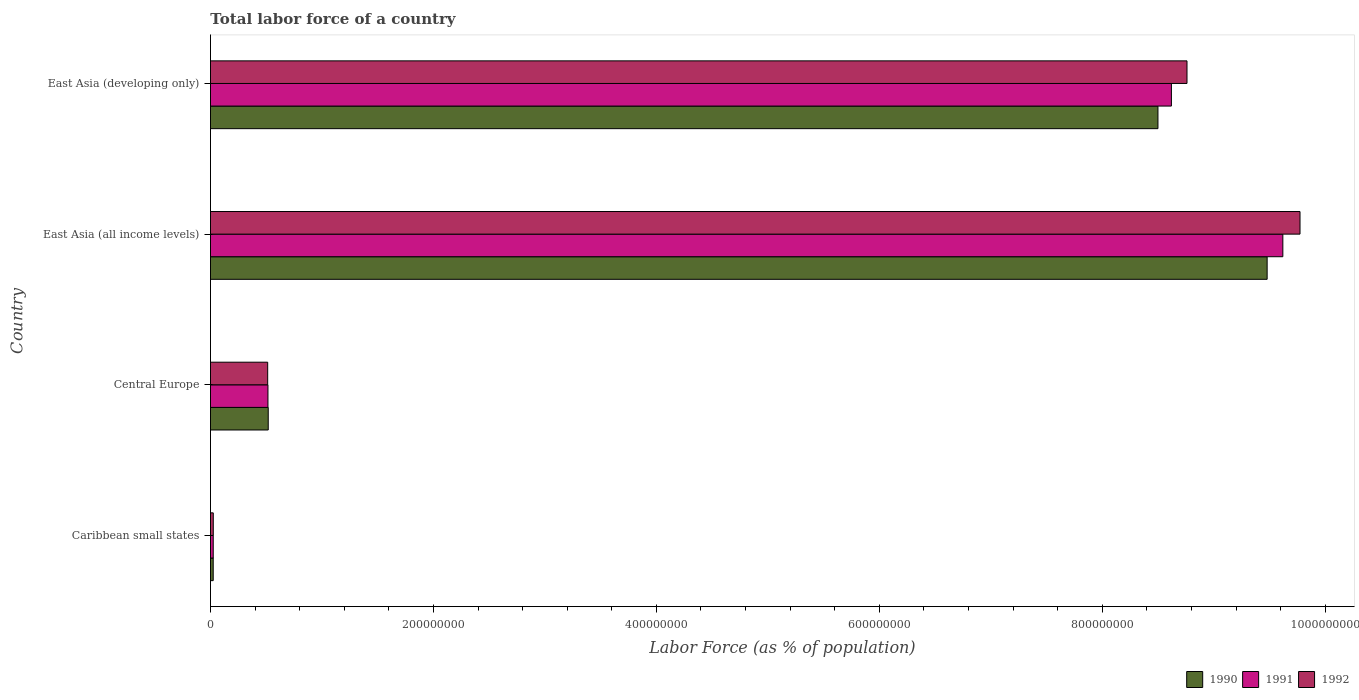How many different coloured bars are there?
Give a very brief answer. 3. Are the number of bars on each tick of the Y-axis equal?
Your answer should be very brief. Yes. How many bars are there on the 4th tick from the top?
Your answer should be compact. 3. How many bars are there on the 3rd tick from the bottom?
Keep it short and to the point. 3. What is the label of the 1st group of bars from the top?
Provide a short and direct response. East Asia (developing only). What is the percentage of labor force in 1990 in East Asia (developing only)?
Offer a very short reply. 8.50e+08. Across all countries, what is the maximum percentage of labor force in 1990?
Your answer should be very brief. 9.48e+08. Across all countries, what is the minimum percentage of labor force in 1992?
Make the answer very short. 2.52e+06. In which country was the percentage of labor force in 1991 maximum?
Provide a succinct answer. East Asia (all income levels). In which country was the percentage of labor force in 1992 minimum?
Keep it short and to the point. Caribbean small states. What is the total percentage of labor force in 1992 in the graph?
Your response must be concise. 1.91e+09. What is the difference between the percentage of labor force in 1990 in Caribbean small states and that in East Asia (all income levels)?
Your answer should be very brief. -9.45e+08. What is the difference between the percentage of labor force in 1990 in East Asia (all income levels) and the percentage of labor force in 1992 in Central Europe?
Keep it short and to the point. 8.97e+08. What is the average percentage of labor force in 1992 per country?
Provide a succinct answer. 4.77e+08. What is the difference between the percentage of labor force in 1992 and percentage of labor force in 1990 in East Asia (all income levels)?
Your response must be concise. 2.95e+07. In how many countries, is the percentage of labor force in 1991 greater than 680000000 %?
Make the answer very short. 2. What is the ratio of the percentage of labor force in 1992 in Caribbean small states to that in East Asia (developing only)?
Offer a very short reply. 0. Is the percentage of labor force in 1992 in East Asia (all income levels) less than that in East Asia (developing only)?
Offer a very short reply. No. What is the difference between the highest and the second highest percentage of labor force in 1991?
Make the answer very short. 1.00e+08. What is the difference between the highest and the lowest percentage of labor force in 1992?
Your response must be concise. 9.75e+08. What does the 1st bar from the bottom in East Asia (developing only) represents?
Offer a very short reply. 1990. Are all the bars in the graph horizontal?
Make the answer very short. Yes. How many countries are there in the graph?
Your answer should be very brief. 4. What is the difference between two consecutive major ticks on the X-axis?
Offer a terse response. 2.00e+08. What is the title of the graph?
Give a very brief answer. Total labor force of a country. What is the label or title of the X-axis?
Your answer should be very brief. Labor Force (as % of population). What is the Labor Force (as % of population) of 1990 in Caribbean small states?
Give a very brief answer. 2.47e+06. What is the Labor Force (as % of population) of 1991 in Caribbean small states?
Make the answer very short. 2.48e+06. What is the Labor Force (as % of population) of 1992 in Caribbean small states?
Provide a short and direct response. 2.52e+06. What is the Labor Force (as % of population) of 1990 in Central Europe?
Your answer should be compact. 5.18e+07. What is the Labor Force (as % of population) of 1991 in Central Europe?
Ensure brevity in your answer.  5.16e+07. What is the Labor Force (as % of population) in 1992 in Central Europe?
Ensure brevity in your answer.  5.13e+07. What is the Labor Force (as % of population) of 1990 in East Asia (all income levels)?
Offer a very short reply. 9.48e+08. What is the Labor Force (as % of population) of 1991 in East Asia (all income levels)?
Ensure brevity in your answer.  9.62e+08. What is the Labor Force (as % of population) in 1992 in East Asia (all income levels)?
Provide a succinct answer. 9.77e+08. What is the Labor Force (as % of population) in 1990 in East Asia (developing only)?
Provide a succinct answer. 8.50e+08. What is the Labor Force (as % of population) in 1991 in East Asia (developing only)?
Keep it short and to the point. 8.62e+08. What is the Labor Force (as % of population) of 1992 in East Asia (developing only)?
Provide a succinct answer. 8.76e+08. Across all countries, what is the maximum Labor Force (as % of population) of 1990?
Your response must be concise. 9.48e+08. Across all countries, what is the maximum Labor Force (as % of population) of 1991?
Your response must be concise. 9.62e+08. Across all countries, what is the maximum Labor Force (as % of population) in 1992?
Offer a terse response. 9.77e+08. Across all countries, what is the minimum Labor Force (as % of population) of 1990?
Ensure brevity in your answer.  2.47e+06. Across all countries, what is the minimum Labor Force (as % of population) in 1991?
Provide a short and direct response. 2.48e+06. Across all countries, what is the minimum Labor Force (as % of population) in 1992?
Your answer should be compact. 2.52e+06. What is the total Labor Force (as % of population) of 1990 in the graph?
Provide a short and direct response. 1.85e+09. What is the total Labor Force (as % of population) of 1991 in the graph?
Your response must be concise. 1.88e+09. What is the total Labor Force (as % of population) in 1992 in the graph?
Your answer should be compact. 1.91e+09. What is the difference between the Labor Force (as % of population) of 1990 in Caribbean small states and that in Central Europe?
Ensure brevity in your answer.  -4.93e+07. What is the difference between the Labor Force (as % of population) in 1991 in Caribbean small states and that in Central Europe?
Ensure brevity in your answer.  -4.91e+07. What is the difference between the Labor Force (as % of population) in 1992 in Caribbean small states and that in Central Europe?
Ensure brevity in your answer.  -4.88e+07. What is the difference between the Labor Force (as % of population) in 1990 in Caribbean small states and that in East Asia (all income levels)?
Give a very brief answer. -9.45e+08. What is the difference between the Labor Force (as % of population) of 1991 in Caribbean small states and that in East Asia (all income levels)?
Make the answer very short. -9.60e+08. What is the difference between the Labor Force (as % of population) of 1992 in Caribbean small states and that in East Asia (all income levels)?
Provide a succinct answer. -9.75e+08. What is the difference between the Labor Force (as % of population) in 1990 in Caribbean small states and that in East Asia (developing only)?
Make the answer very short. -8.47e+08. What is the difference between the Labor Force (as % of population) in 1991 in Caribbean small states and that in East Asia (developing only)?
Your answer should be compact. -8.60e+08. What is the difference between the Labor Force (as % of population) in 1992 in Caribbean small states and that in East Asia (developing only)?
Offer a very short reply. -8.73e+08. What is the difference between the Labor Force (as % of population) of 1990 in Central Europe and that in East Asia (all income levels)?
Keep it short and to the point. -8.96e+08. What is the difference between the Labor Force (as % of population) of 1991 in Central Europe and that in East Asia (all income levels)?
Offer a terse response. -9.10e+08. What is the difference between the Labor Force (as % of population) of 1992 in Central Europe and that in East Asia (all income levels)?
Your response must be concise. -9.26e+08. What is the difference between the Labor Force (as % of population) in 1990 in Central Europe and that in East Asia (developing only)?
Provide a short and direct response. -7.98e+08. What is the difference between the Labor Force (as % of population) of 1991 in Central Europe and that in East Asia (developing only)?
Make the answer very short. -8.10e+08. What is the difference between the Labor Force (as % of population) of 1992 in Central Europe and that in East Asia (developing only)?
Provide a succinct answer. -8.25e+08. What is the difference between the Labor Force (as % of population) in 1990 in East Asia (all income levels) and that in East Asia (developing only)?
Give a very brief answer. 9.79e+07. What is the difference between the Labor Force (as % of population) of 1991 in East Asia (all income levels) and that in East Asia (developing only)?
Your answer should be compact. 1.00e+08. What is the difference between the Labor Force (as % of population) in 1992 in East Asia (all income levels) and that in East Asia (developing only)?
Give a very brief answer. 1.01e+08. What is the difference between the Labor Force (as % of population) in 1990 in Caribbean small states and the Labor Force (as % of population) in 1991 in Central Europe?
Give a very brief answer. -4.91e+07. What is the difference between the Labor Force (as % of population) of 1990 in Caribbean small states and the Labor Force (as % of population) of 1992 in Central Europe?
Ensure brevity in your answer.  -4.89e+07. What is the difference between the Labor Force (as % of population) of 1991 in Caribbean small states and the Labor Force (as % of population) of 1992 in Central Europe?
Your answer should be very brief. -4.89e+07. What is the difference between the Labor Force (as % of population) in 1990 in Caribbean small states and the Labor Force (as % of population) in 1991 in East Asia (all income levels)?
Your answer should be compact. -9.60e+08. What is the difference between the Labor Force (as % of population) in 1990 in Caribbean small states and the Labor Force (as % of population) in 1992 in East Asia (all income levels)?
Ensure brevity in your answer.  -9.75e+08. What is the difference between the Labor Force (as % of population) of 1991 in Caribbean small states and the Labor Force (as % of population) of 1992 in East Asia (all income levels)?
Provide a succinct answer. -9.75e+08. What is the difference between the Labor Force (as % of population) of 1990 in Caribbean small states and the Labor Force (as % of population) of 1991 in East Asia (developing only)?
Provide a short and direct response. -8.60e+08. What is the difference between the Labor Force (as % of population) in 1990 in Caribbean small states and the Labor Force (as % of population) in 1992 in East Asia (developing only)?
Give a very brief answer. -8.74e+08. What is the difference between the Labor Force (as % of population) of 1991 in Caribbean small states and the Labor Force (as % of population) of 1992 in East Asia (developing only)?
Make the answer very short. -8.74e+08. What is the difference between the Labor Force (as % of population) of 1990 in Central Europe and the Labor Force (as % of population) of 1991 in East Asia (all income levels)?
Keep it short and to the point. -9.10e+08. What is the difference between the Labor Force (as % of population) of 1990 in Central Europe and the Labor Force (as % of population) of 1992 in East Asia (all income levels)?
Your response must be concise. -9.26e+08. What is the difference between the Labor Force (as % of population) in 1991 in Central Europe and the Labor Force (as % of population) in 1992 in East Asia (all income levels)?
Your response must be concise. -9.26e+08. What is the difference between the Labor Force (as % of population) of 1990 in Central Europe and the Labor Force (as % of population) of 1991 in East Asia (developing only)?
Your response must be concise. -8.10e+08. What is the difference between the Labor Force (as % of population) in 1990 in Central Europe and the Labor Force (as % of population) in 1992 in East Asia (developing only)?
Offer a terse response. -8.24e+08. What is the difference between the Labor Force (as % of population) of 1991 in Central Europe and the Labor Force (as % of population) of 1992 in East Asia (developing only)?
Make the answer very short. -8.24e+08. What is the difference between the Labor Force (as % of population) in 1990 in East Asia (all income levels) and the Labor Force (as % of population) in 1991 in East Asia (developing only)?
Offer a terse response. 8.59e+07. What is the difference between the Labor Force (as % of population) of 1990 in East Asia (all income levels) and the Labor Force (as % of population) of 1992 in East Asia (developing only)?
Provide a short and direct response. 7.19e+07. What is the difference between the Labor Force (as % of population) in 1991 in East Asia (all income levels) and the Labor Force (as % of population) in 1992 in East Asia (developing only)?
Provide a succinct answer. 8.60e+07. What is the average Labor Force (as % of population) in 1990 per country?
Your answer should be compact. 4.63e+08. What is the average Labor Force (as % of population) in 1991 per country?
Provide a short and direct response. 4.70e+08. What is the average Labor Force (as % of population) of 1992 per country?
Ensure brevity in your answer.  4.77e+08. What is the difference between the Labor Force (as % of population) in 1990 and Labor Force (as % of population) in 1991 in Caribbean small states?
Give a very brief answer. -9246. What is the difference between the Labor Force (as % of population) in 1990 and Labor Force (as % of population) in 1992 in Caribbean small states?
Provide a short and direct response. -5.15e+04. What is the difference between the Labor Force (as % of population) of 1991 and Labor Force (as % of population) of 1992 in Caribbean small states?
Your answer should be very brief. -4.23e+04. What is the difference between the Labor Force (as % of population) in 1990 and Labor Force (as % of population) in 1991 in Central Europe?
Your answer should be very brief. 2.48e+05. What is the difference between the Labor Force (as % of population) in 1990 and Labor Force (as % of population) in 1992 in Central Europe?
Your answer should be very brief. 4.84e+05. What is the difference between the Labor Force (as % of population) of 1991 and Labor Force (as % of population) of 1992 in Central Europe?
Your response must be concise. 2.36e+05. What is the difference between the Labor Force (as % of population) in 1990 and Labor Force (as % of population) in 1991 in East Asia (all income levels)?
Keep it short and to the point. -1.41e+07. What is the difference between the Labor Force (as % of population) of 1990 and Labor Force (as % of population) of 1992 in East Asia (all income levels)?
Your response must be concise. -2.95e+07. What is the difference between the Labor Force (as % of population) in 1991 and Labor Force (as % of population) in 1992 in East Asia (all income levels)?
Make the answer very short. -1.54e+07. What is the difference between the Labor Force (as % of population) of 1990 and Labor Force (as % of population) of 1991 in East Asia (developing only)?
Make the answer very short. -1.21e+07. What is the difference between the Labor Force (as % of population) of 1990 and Labor Force (as % of population) of 1992 in East Asia (developing only)?
Offer a very short reply. -2.60e+07. What is the difference between the Labor Force (as % of population) of 1991 and Labor Force (as % of population) of 1992 in East Asia (developing only)?
Offer a very short reply. -1.40e+07. What is the ratio of the Labor Force (as % of population) of 1990 in Caribbean small states to that in Central Europe?
Your answer should be compact. 0.05. What is the ratio of the Labor Force (as % of population) of 1991 in Caribbean small states to that in Central Europe?
Provide a succinct answer. 0.05. What is the ratio of the Labor Force (as % of population) of 1992 in Caribbean small states to that in Central Europe?
Make the answer very short. 0.05. What is the ratio of the Labor Force (as % of population) of 1990 in Caribbean small states to that in East Asia (all income levels)?
Make the answer very short. 0. What is the ratio of the Labor Force (as % of population) in 1991 in Caribbean small states to that in East Asia (all income levels)?
Ensure brevity in your answer.  0. What is the ratio of the Labor Force (as % of population) in 1992 in Caribbean small states to that in East Asia (all income levels)?
Offer a terse response. 0. What is the ratio of the Labor Force (as % of population) of 1990 in Caribbean small states to that in East Asia (developing only)?
Your answer should be compact. 0. What is the ratio of the Labor Force (as % of population) of 1991 in Caribbean small states to that in East Asia (developing only)?
Give a very brief answer. 0. What is the ratio of the Labor Force (as % of population) of 1992 in Caribbean small states to that in East Asia (developing only)?
Keep it short and to the point. 0. What is the ratio of the Labor Force (as % of population) of 1990 in Central Europe to that in East Asia (all income levels)?
Make the answer very short. 0.05. What is the ratio of the Labor Force (as % of population) in 1991 in Central Europe to that in East Asia (all income levels)?
Keep it short and to the point. 0.05. What is the ratio of the Labor Force (as % of population) in 1992 in Central Europe to that in East Asia (all income levels)?
Ensure brevity in your answer.  0.05. What is the ratio of the Labor Force (as % of population) in 1990 in Central Europe to that in East Asia (developing only)?
Provide a succinct answer. 0.06. What is the ratio of the Labor Force (as % of population) in 1991 in Central Europe to that in East Asia (developing only)?
Your answer should be compact. 0.06. What is the ratio of the Labor Force (as % of population) in 1992 in Central Europe to that in East Asia (developing only)?
Make the answer very short. 0.06. What is the ratio of the Labor Force (as % of population) in 1990 in East Asia (all income levels) to that in East Asia (developing only)?
Your answer should be compact. 1.12. What is the ratio of the Labor Force (as % of population) of 1991 in East Asia (all income levels) to that in East Asia (developing only)?
Ensure brevity in your answer.  1.12. What is the ratio of the Labor Force (as % of population) in 1992 in East Asia (all income levels) to that in East Asia (developing only)?
Your answer should be compact. 1.12. What is the difference between the highest and the second highest Labor Force (as % of population) of 1990?
Your answer should be very brief. 9.79e+07. What is the difference between the highest and the second highest Labor Force (as % of population) in 1991?
Ensure brevity in your answer.  1.00e+08. What is the difference between the highest and the second highest Labor Force (as % of population) of 1992?
Offer a very short reply. 1.01e+08. What is the difference between the highest and the lowest Labor Force (as % of population) in 1990?
Offer a very short reply. 9.45e+08. What is the difference between the highest and the lowest Labor Force (as % of population) in 1991?
Ensure brevity in your answer.  9.60e+08. What is the difference between the highest and the lowest Labor Force (as % of population) of 1992?
Ensure brevity in your answer.  9.75e+08. 